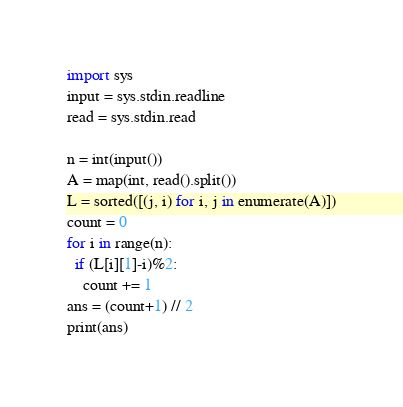Convert code to text. <code><loc_0><loc_0><loc_500><loc_500><_Python_>import sys
input = sys.stdin.readline
read = sys.stdin.read

n = int(input())
A = map(int, read().split())
L = sorted([(j, i) for i, j in enumerate(A)])
count = 0
for i in range(n):
  if (L[i][1]-i)%2:
    count += 1
ans = (count+1) // 2
print(ans)</code> 